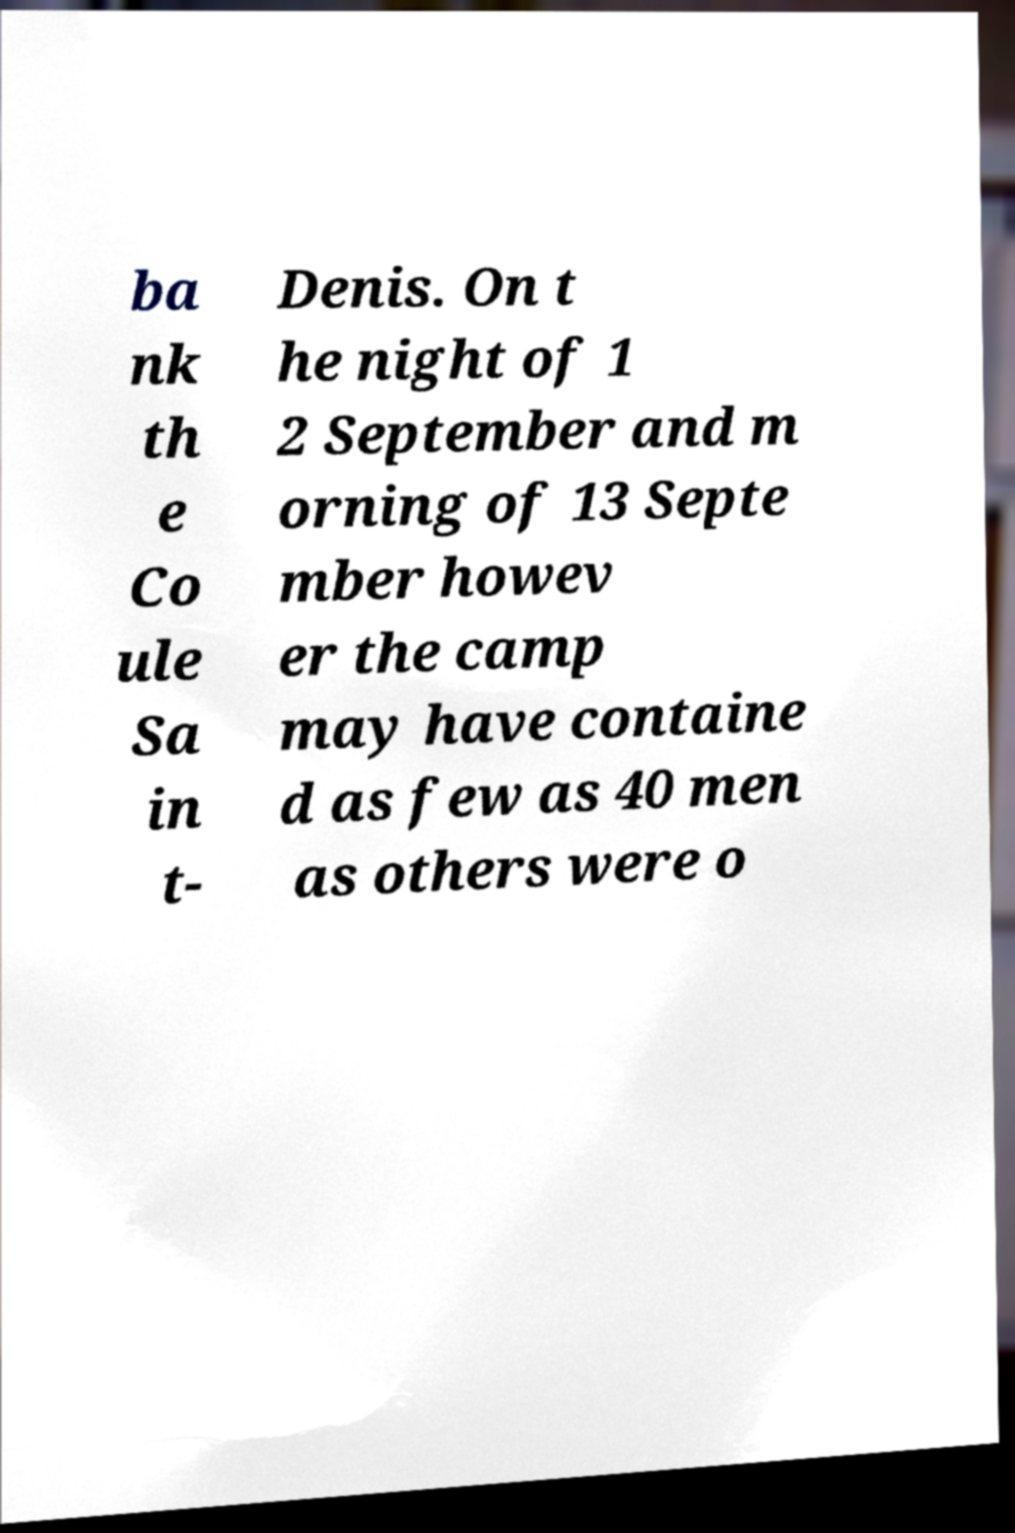For documentation purposes, I need the text within this image transcribed. Could you provide that? ba nk th e Co ule Sa in t- Denis. On t he night of 1 2 September and m orning of 13 Septe mber howev er the camp may have containe d as few as 40 men as others were o 